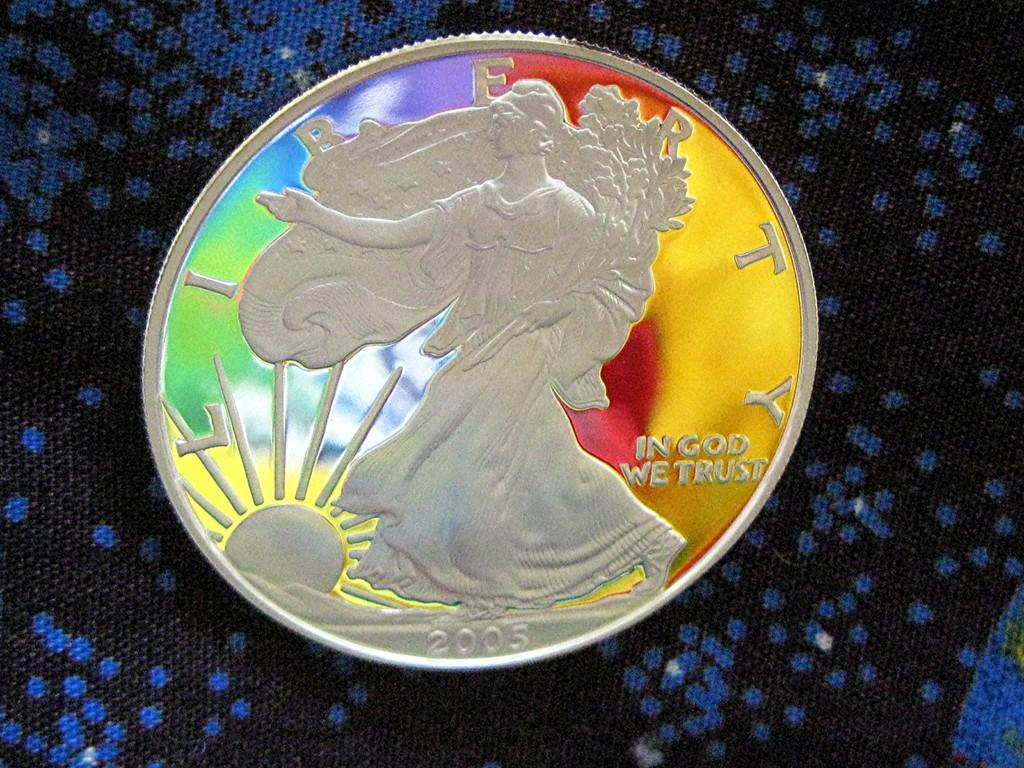<image>
Provide a brief description of the given image. A Liberty coin has been painted with a design. 